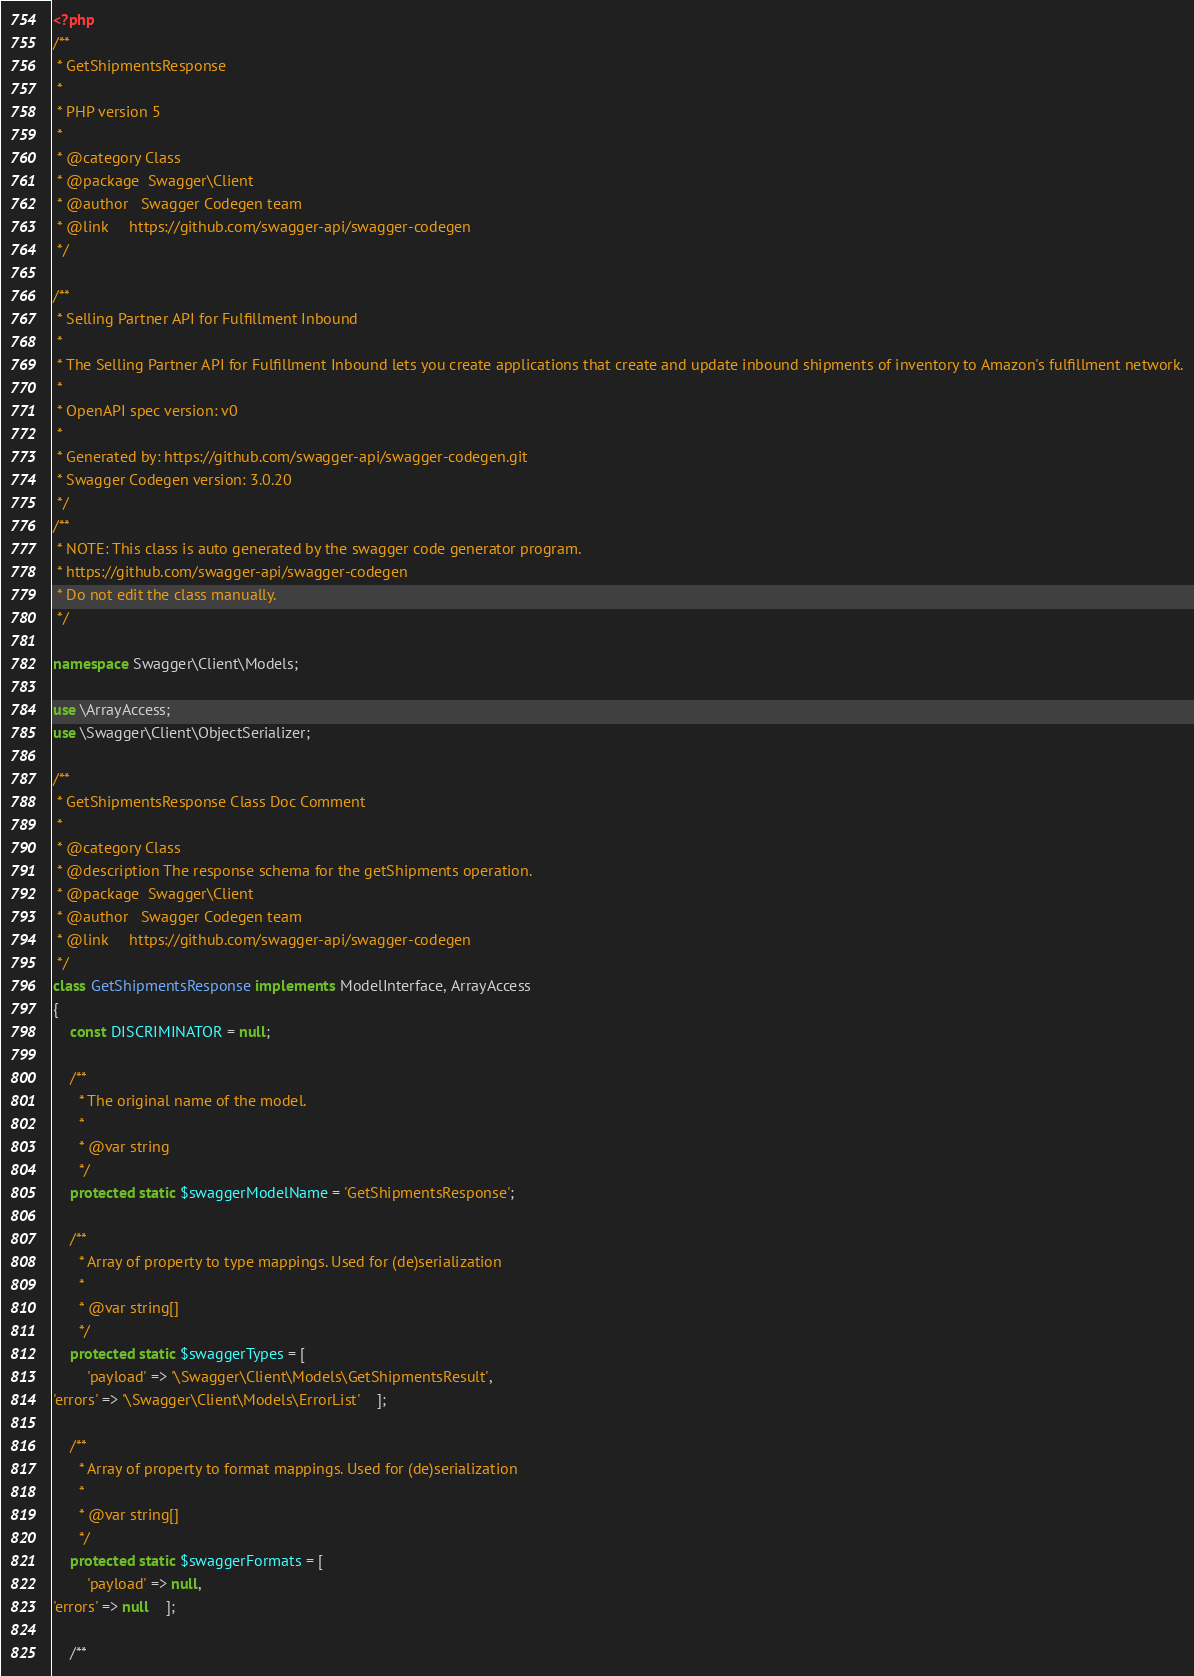<code> <loc_0><loc_0><loc_500><loc_500><_PHP_><?php
/**
 * GetShipmentsResponse
 *
 * PHP version 5
 *
 * @category Class
 * @package  Swagger\Client
 * @author   Swagger Codegen team
 * @link     https://github.com/swagger-api/swagger-codegen
 */

/**
 * Selling Partner API for Fulfillment Inbound
 *
 * The Selling Partner API for Fulfillment Inbound lets you create applications that create and update inbound shipments of inventory to Amazon's fulfillment network.
 *
 * OpenAPI spec version: v0
 * 
 * Generated by: https://github.com/swagger-api/swagger-codegen.git
 * Swagger Codegen version: 3.0.20
 */
/**
 * NOTE: This class is auto generated by the swagger code generator program.
 * https://github.com/swagger-api/swagger-codegen
 * Do not edit the class manually.
 */

namespace Swagger\Client\Models;

use \ArrayAccess;
use \Swagger\Client\ObjectSerializer;

/**
 * GetShipmentsResponse Class Doc Comment
 *
 * @category Class
 * @description The response schema for the getShipments operation.
 * @package  Swagger\Client
 * @author   Swagger Codegen team
 * @link     https://github.com/swagger-api/swagger-codegen
 */
class GetShipmentsResponse implements ModelInterface, ArrayAccess
{
    const DISCRIMINATOR = null;

    /**
      * The original name of the model.
      *
      * @var string
      */
    protected static $swaggerModelName = 'GetShipmentsResponse';

    /**
      * Array of property to type mappings. Used for (de)serialization
      *
      * @var string[]
      */
    protected static $swaggerTypes = [
        'payload' => '\Swagger\Client\Models\GetShipmentsResult',
'errors' => '\Swagger\Client\Models\ErrorList'    ];

    /**
      * Array of property to format mappings. Used for (de)serialization
      *
      * @var string[]
      */
    protected static $swaggerFormats = [
        'payload' => null,
'errors' => null    ];

    /**</code> 